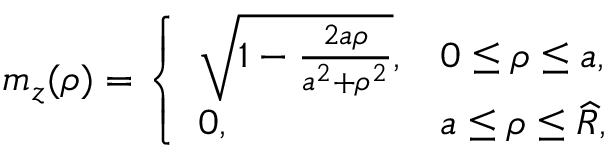Convert formula to latex. <formula><loc_0><loc_0><loc_500><loc_500>\begin{array} { r } { m _ { z } ( \rho ) = \left \{ \begin{array} { l l } { \sqrt { 1 - \frac { 2 a \rho } { a ^ { 2 } + \rho ^ { 2 } } } , } & { 0 \leq \rho \leq a , } \\ { 0 , } & { a \leq \rho \leq \widehat { R } , } \end{array} } \end{array}</formula> 